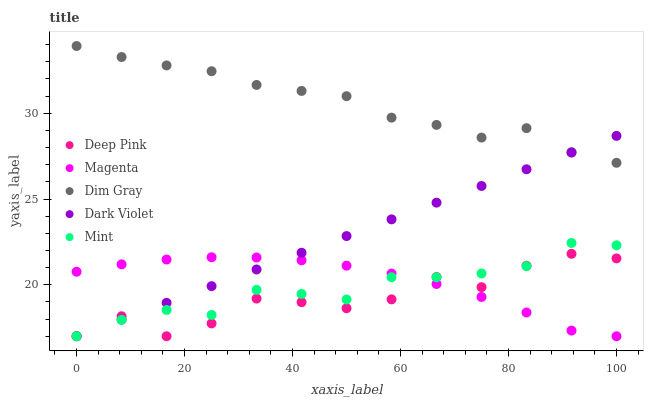Does Deep Pink have the minimum area under the curve?
Answer yes or no. Yes. Does Dim Gray have the maximum area under the curve?
Answer yes or no. Yes. Does Mint have the minimum area under the curve?
Answer yes or no. No. Does Mint have the maximum area under the curve?
Answer yes or no. No. Is Dark Violet the smoothest?
Answer yes or no. Yes. Is Deep Pink the roughest?
Answer yes or no. Yes. Is Mint the smoothest?
Answer yes or no. No. Is Mint the roughest?
Answer yes or no. No. Does Magenta have the lowest value?
Answer yes or no. Yes. Does Dim Gray have the lowest value?
Answer yes or no. No. Does Dim Gray have the highest value?
Answer yes or no. Yes. Does Deep Pink have the highest value?
Answer yes or no. No. Is Deep Pink less than Dim Gray?
Answer yes or no. Yes. Is Dim Gray greater than Deep Pink?
Answer yes or no. Yes. Does Deep Pink intersect Dark Violet?
Answer yes or no. Yes. Is Deep Pink less than Dark Violet?
Answer yes or no. No. Is Deep Pink greater than Dark Violet?
Answer yes or no. No. Does Deep Pink intersect Dim Gray?
Answer yes or no. No. 